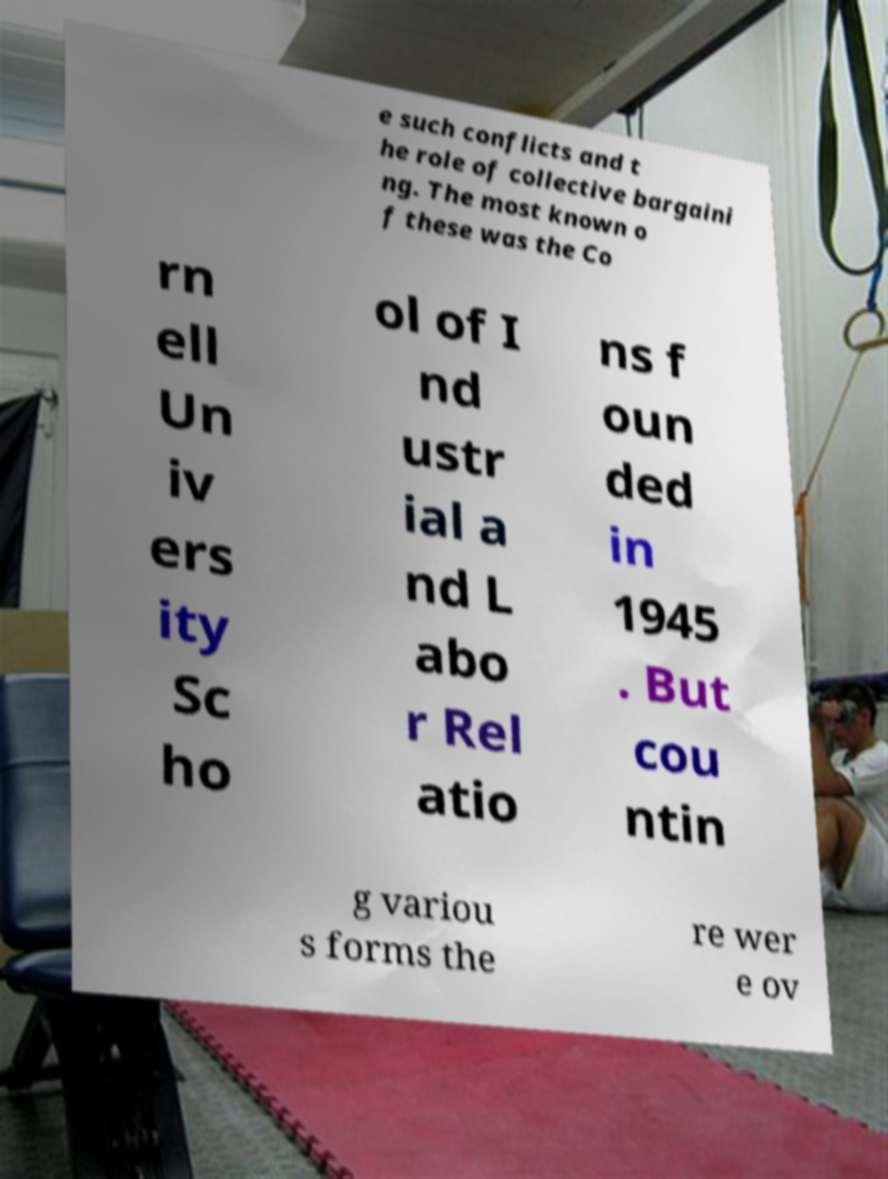There's text embedded in this image that I need extracted. Can you transcribe it verbatim? e such conflicts and t he role of collective bargaini ng. The most known o f these was the Co rn ell Un iv ers ity Sc ho ol of I nd ustr ial a nd L abo r Rel atio ns f oun ded in 1945 . But cou ntin g variou s forms the re wer e ov 